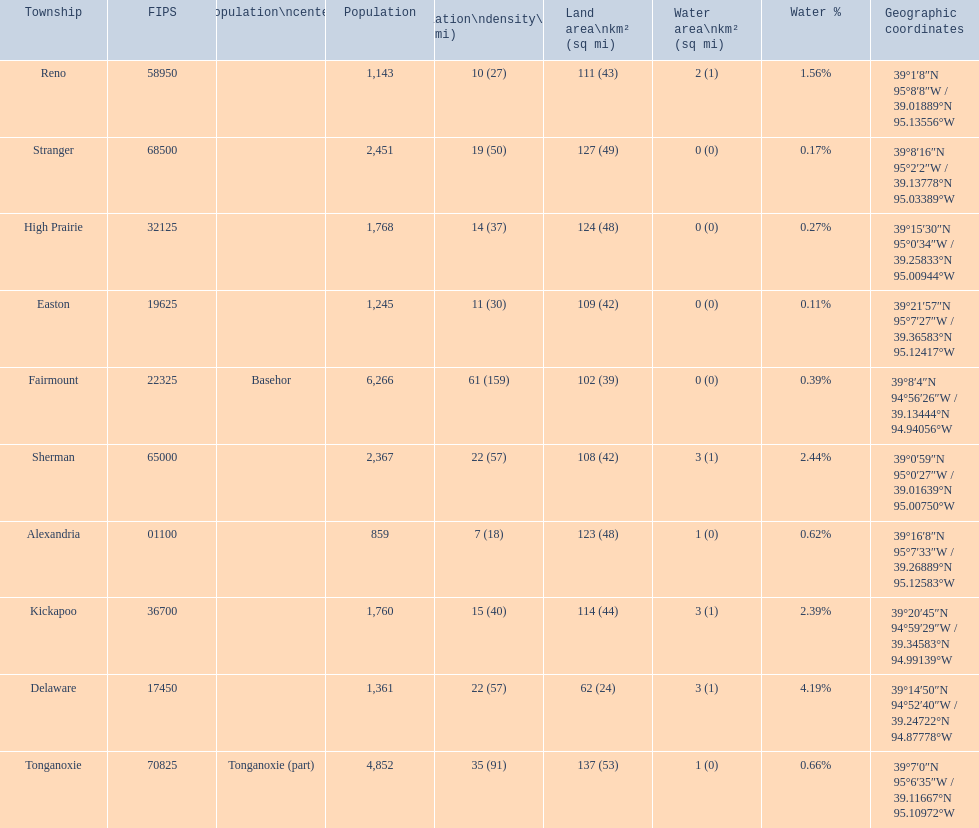How many townships have populations over 2,000? 4. 